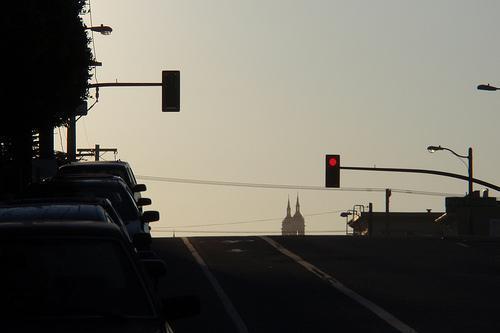How many red lights?
Give a very brief answer. 1. 